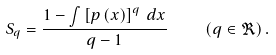<formula> <loc_0><loc_0><loc_500><loc_500>S _ { q } = \frac { 1 - \int \left [ p \left ( x \right ) \right ] ^ { q } \, d x } { q - 1 } \quad \left ( q \in \Re \right ) .</formula> 